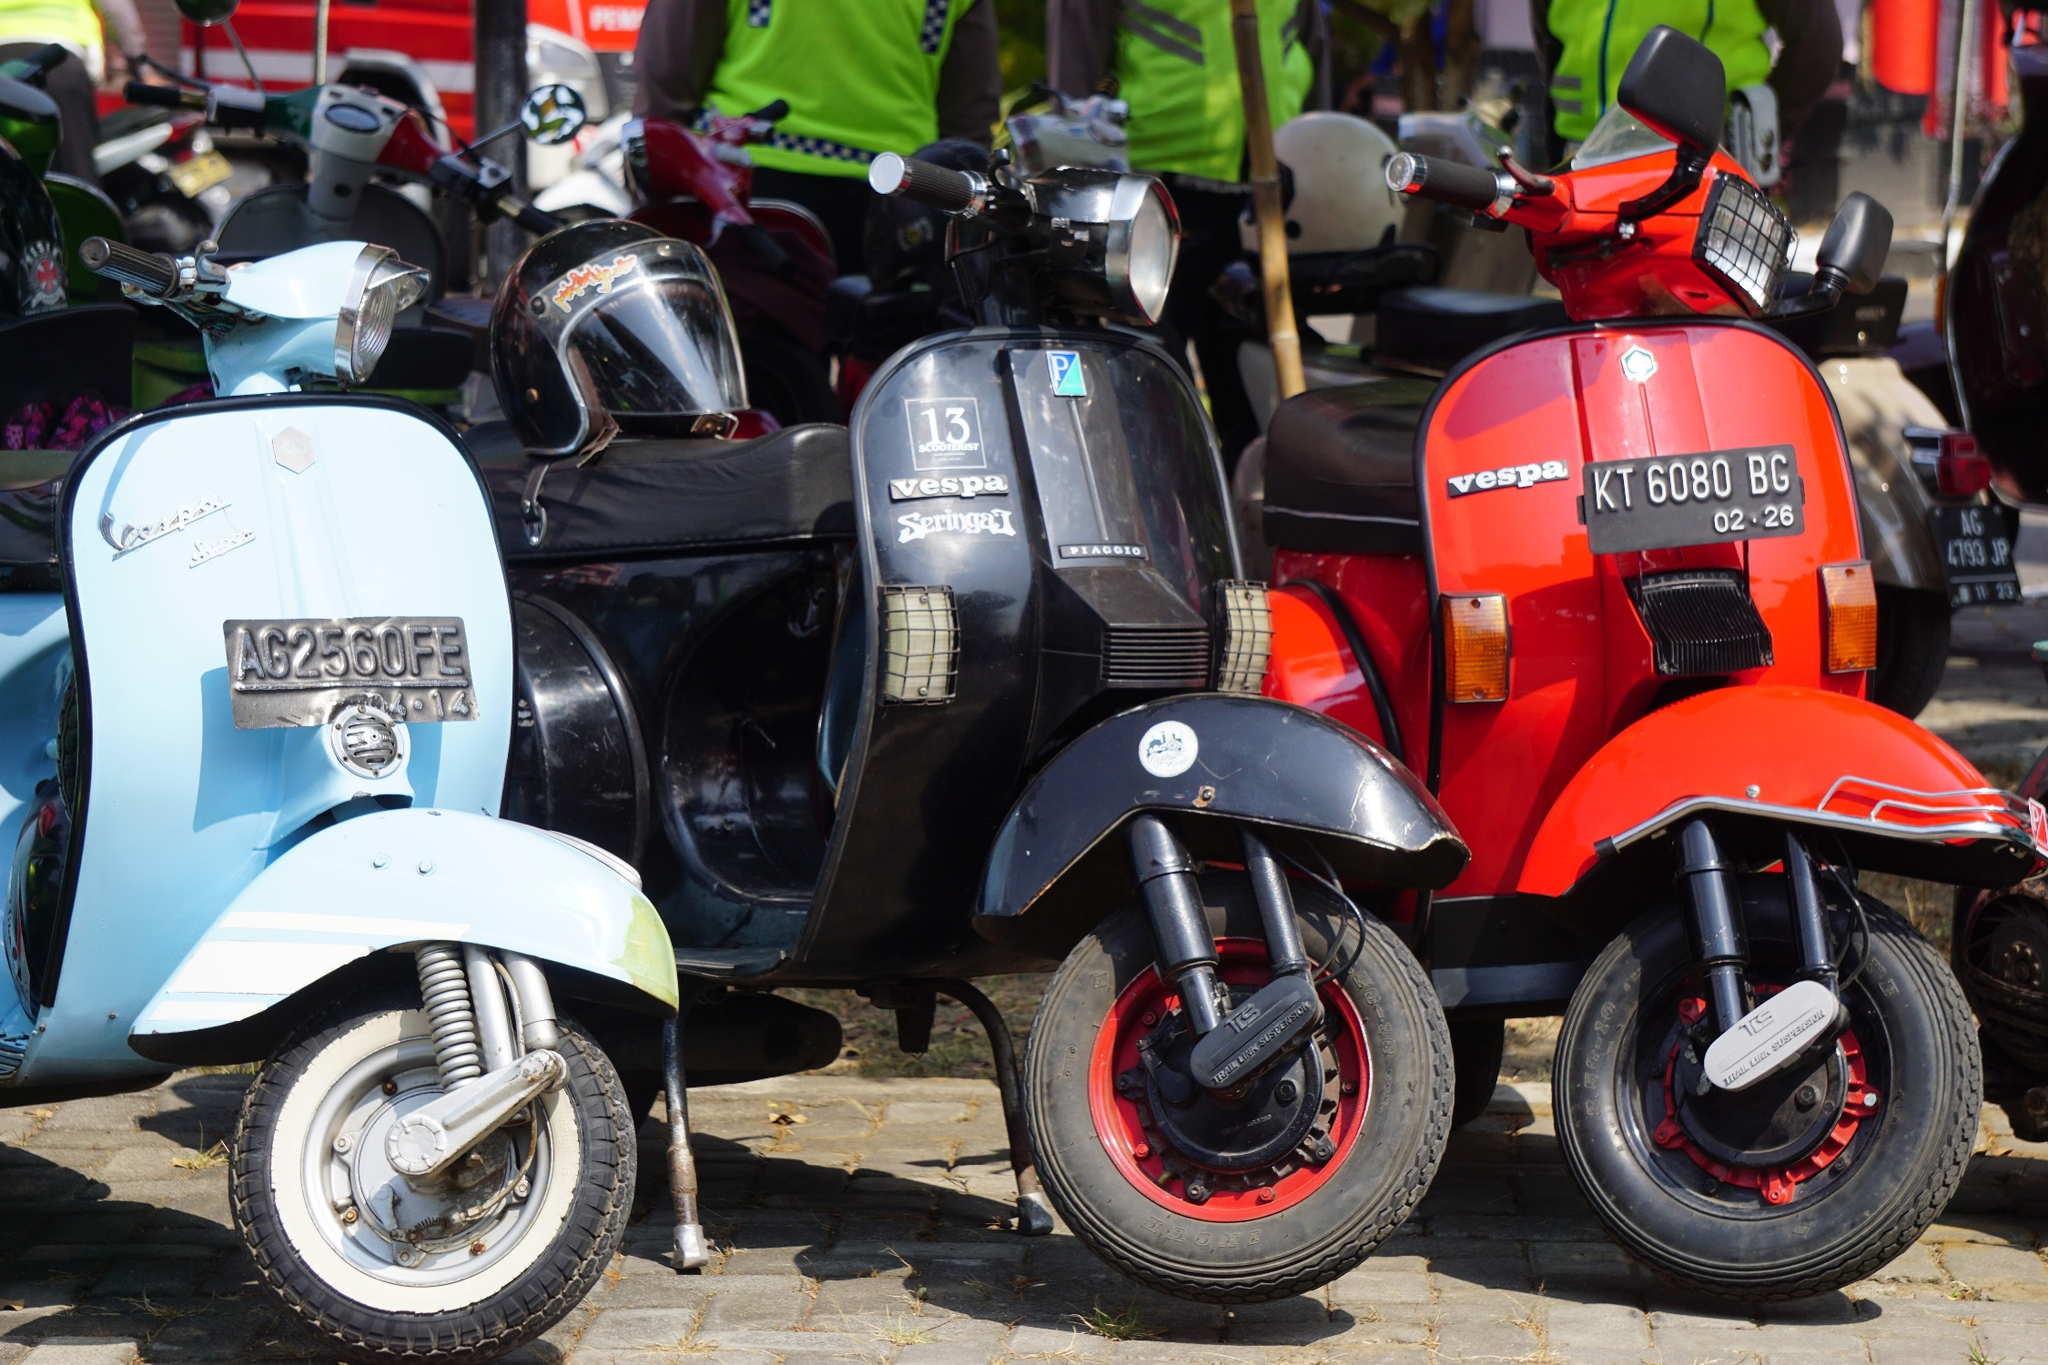Describe the community or town one might imagine surrounding this scene. This scene is likely set in a picturesque, quaint European town known for its cobblestone streets and charming architecture. The town could be bustling with vibrant markets, cozy cafes with outdoor seating, and bakeries emanating the delightful aroma of freshly baked bread. Narrow alleyways with colorful facades and flower boxes on windowsills contribute to the town's allure, and friendly locals often greet each other as they go about their day. The Vespas parked on the street hint at a close-knit community that values both tradition and a leisurely pace of life. What kind of events or activities might take place in such a town? In this idyllic town, one could imagine a variety of events and activities bringing the community together. There might be weekly farmers' markets where residents buy fresh produce and handcrafted goods, or cultural festivals celebrating local heritage with music, dance, and traditional dress. Outdoor concerts and art fairs could take place in the town square, while children play nearby. The town might also host vespa rallies, where enthusiasts gather with their scooters, showcasing vintage models and sharing stories of their rides. Additionally, you could envision serene Sunday mornings with families gathering for brunch at local cafes or participating in communal activities like book clubs, knitting circles, or gardening clubs that promote a sense of unity and camaraderie. 